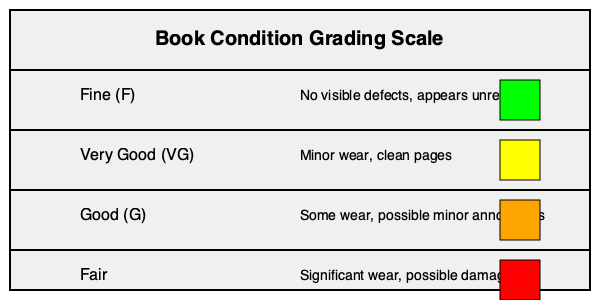Based on the visual grading scale provided, which condition would you assign to a modern first edition book that shows slight yellowing of pages, minimal shelf wear on the dust jacket, and a previous owner's neat signature on the first blank page? To determine the condition of the book, let's analyze it step-by-step using the provided grading scale:

1. Fine (F): This category requires no visible defects and appears unread. Our book shows slight yellowing and minimal shelf wear, so it doesn't meet this criterion.

2. Very Good (VG): This category allows for minor wear and clean pages. Our book fits this description:
   a. Slight yellowing of pages: This is considered minor wear and is common in older books.
   b. Minimal shelf wear on the dust jacket: This falls under the "minor wear" category.
   c. Previous owner's neat signature: While not explicitly mentioned in the scale, a neat signature on the first blank page is generally considered acceptable for a Very Good condition book, especially for modern first editions.

3. Good (G): This category allows for some wear and possible minor annotations. Our book's condition is better than this, as it only shows minimal wear.

4. Fair: This category indicates significant wear and possible damage, which doesn't apply to our book.

Given these considerations, the book best fits the "Very Good (VG)" category. It shows some minor signs of wear and use but is still in overall good condition, which is typical for collectible modern first editions.
Answer: Very Good (VG) 